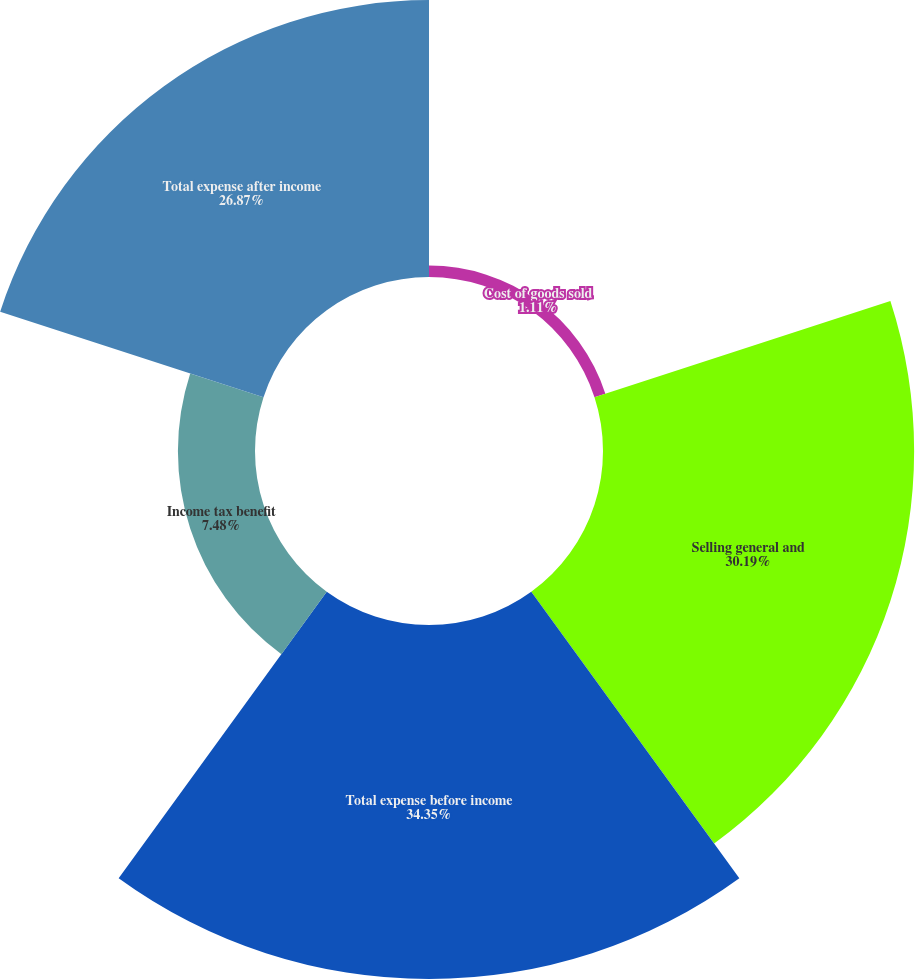Convert chart to OTSL. <chart><loc_0><loc_0><loc_500><loc_500><pie_chart><fcel>Cost of goods sold<fcel>Selling general and<fcel>Total expense before income<fcel>Income tax benefit<fcel>Total expense after income<nl><fcel>1.11%<fcel>30.19%<fcel>34.35%<fcel>7.48%<fcel>26.87%<nl></chart> 